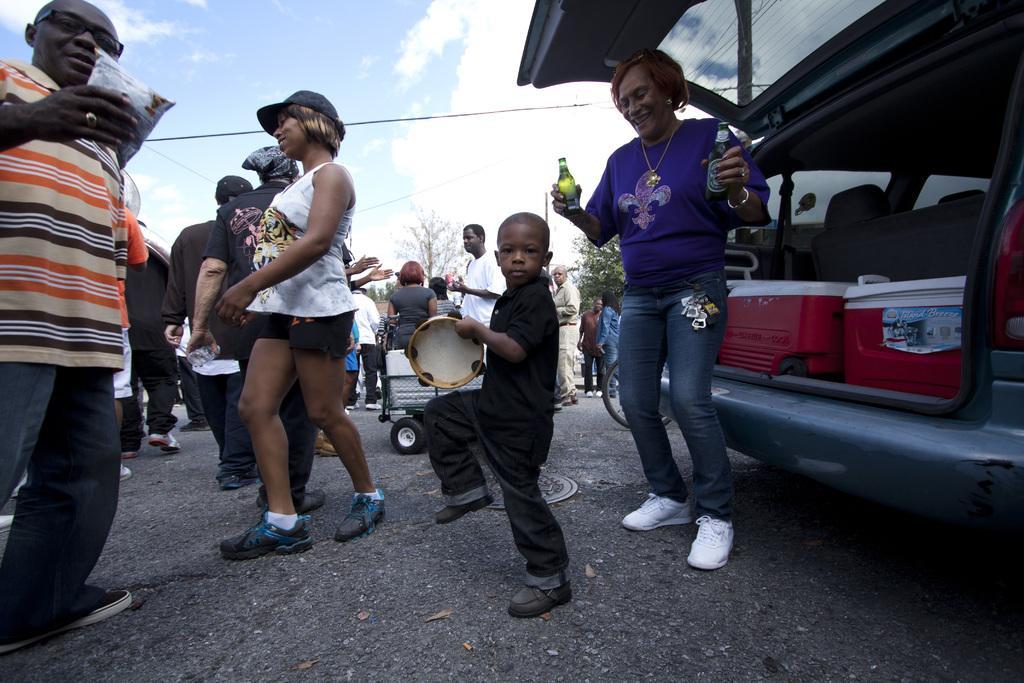Could you give a brief overview of what you see in this image? In this image we can see there are few people are on the road, some are walking and some are dancing. On the right side of the image there is a vehicle parked, in front of the vehicle there is a lady dancing and holding two drink bottles in her hand. In the background there is a sky. 